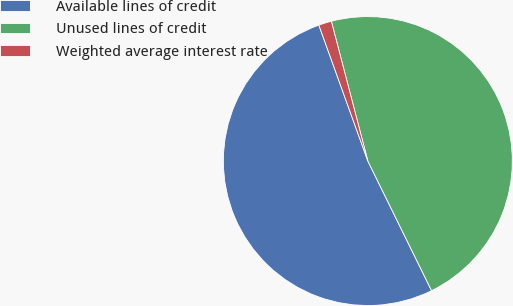Convert chart to OTSL. <chart><loc_0><loc_0><loc_500><loc_500><pie_chart><fcel>Available lines of credit<fcel>Unused lines of credit<fcel>Weighted average interest rate<nl><fcel>51.77%<fcel>46.8%<fcel>1.44%<nl></chart> 